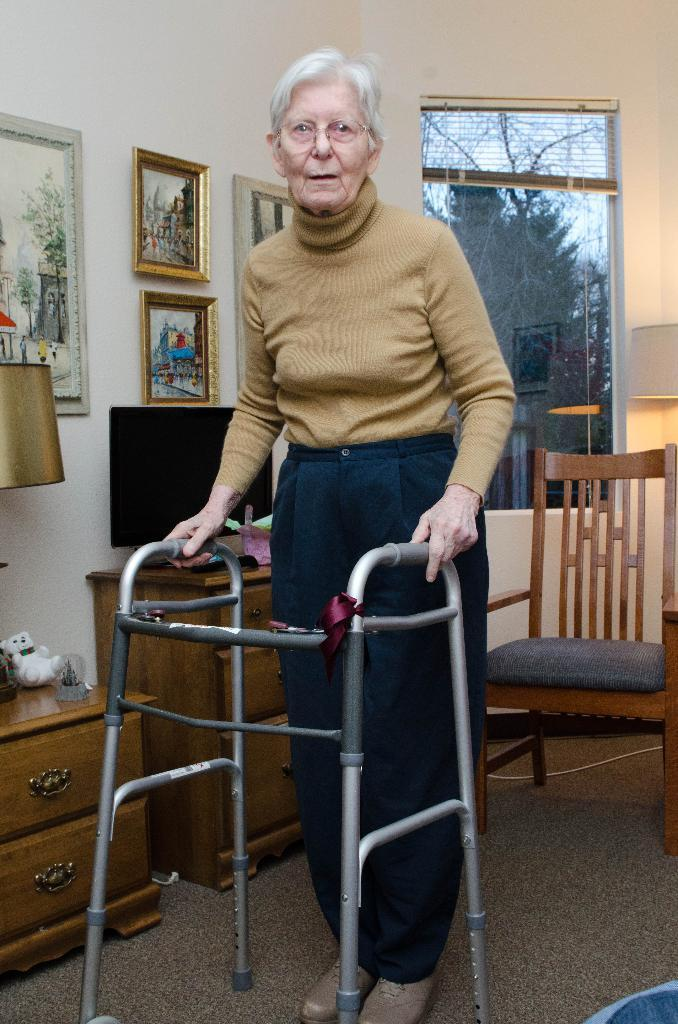Who is the main subject in the image? There is an old woman in the image. How is the old woman positioned in the image? The old woman is standing with the help of a stand. What can be seen in the background of the image? There is a television, a window, and a wall of photo frames in the background of the image. What other object is present in the image? There is a lamp in the image. What type of alarm is the old woman using in the image? There is no alarm present in the image; the old woman is using a stand for support. 